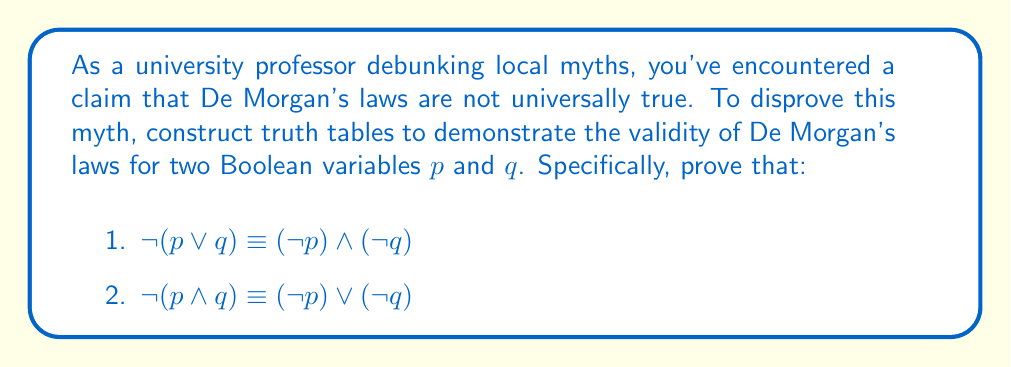Help me with this question. To prove the validity of De Morgan's laws using truth tables, we need to construct tables for both sides of each equivalence and show that they produce identical results for all possible input combinations.

1. For $\neg(p \lor q) \equiv (\neg p) \land (\neg q)$:

Step 1: Construct the truth table for $\neg(p \lor q)$
$$
\begin{array}{|c|c|c|c|c|}
\hline
p & q & p \lor q & \neg(p \lor q) \\
\hline
0 & 0 & 0 & 1 \\
0 & 1 & 1 & 0 \\
1 & 0 & 1 & 0 \\
1 & 1 & 1 & 0 \\
\hline
\end{array}
$$

Step 2: Construct the truth table for $(\neg p) \land (\neg q)$
$$
\begin{array}{|c|c|c|c|c|}
\hline
p & q & \neg p & \neg q & (\neg p) \land (\neg q) \\
\hline
0 & 0 & 1 & 1 & 1 \\
0 & 1 & 1 & 0 & 0 \\
1 & 0 & 0 & 1 & 0 \\
1 & 1 & 0 & 0 & 0 \\
\hline
\end{array}
$$

Step 3: Compare the results of $\neg(p \lor q)$ and $(\neg p) \land (\neg q)$. They are identical for all input combinations.

2. For $\neg(p \land q) \equiv (\neg p) \lor (\neg q)$:

Step 4: Construct the truth table for $\neg(p \land q)$
$$
\begin{array}{|c|c|c|c|}
\hline
p & q & p \land q & \neg(p \land q) \\
\hline
0 & 0 & 0 & 1 \\
0 & 1 & 0 & 1 \\
1 & 0 & 0 & 1 \\
1 & 1 & 1 & 0 \\
\hline
\end{array}
$$

Step 5: Construct the truth table for $(\neg p) \lor (\neg q)$
$$
\begin{array}{|c|c|c|c|c|}
\hline
p & q & \neg p & \neg q & (\neg p) \lor (\neg q) \\
\hline
0 & 0 & 1 & 1 & 1 \\
0 & 1 & 1 & 0 & 1 \\
1 & 0 & 0 & 1 & 1 \\
1 & 1 & 0 & 0 & 0 \\
\hline
\end{array}
$$

Step 6: Compare the results of $\neg(p \land q)$ and $(\neg p) \lor (\neg q)$. They are identical for all input combinations.

Since both equivalences hold true for all possible input combinations, De Morgan's laws are proven valid using truth tables.
Answer: De Morgan's laws are valid: truth tables for $\neg(p \lor q) \equiv (\neg p) \land (\neg q)$ and $\neg(p \land q) \equiv (\neg p) \lor (\neg q)$ show identical results for all input combinations. 